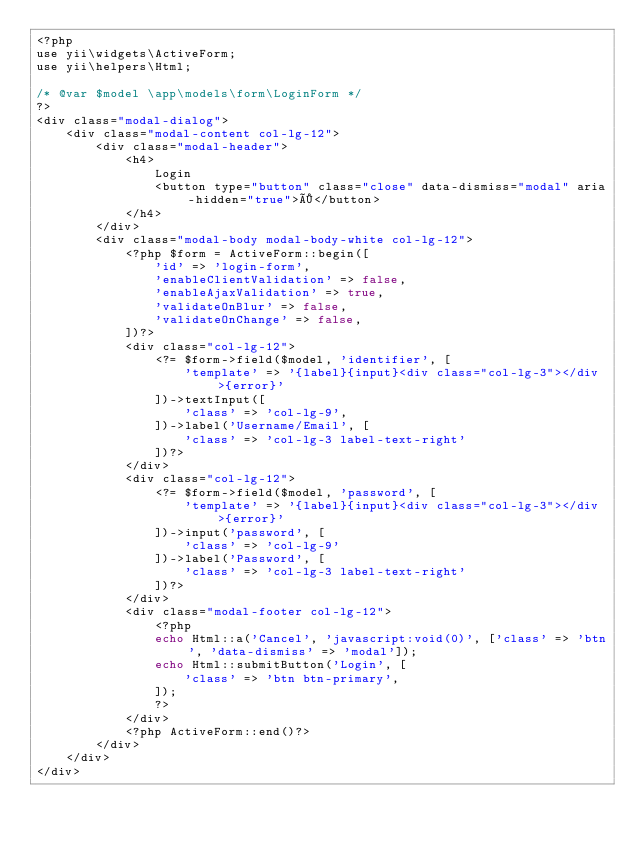Convert code to text. <code><loc_0><loc_0><loc_500><loc_500><_PHP_><?php
use yii\widgets\ActiveForm;
use yii\helpers\Html;

/* @var $model \app\models\form\LoginForm */
?>
<div class="modal-dialog">
    <div class="modal-content col-lg-12">
        <div class="modal-header">
            <h4>
                Login
                <button type="button" class="close" data-dismiss="modal" aria-hidden="true">×</button>
            </h4>
        </div>
        <div class="modal-body modal-body-white col-lg-12">
            <?php $form = ActiveForm::begin([
                'id' => 'login-form',
                'enableClientValidation' => false,
                'enableAjaxValidation' => true,
                'validateOnBlur' => false,
                'validateOnChange' => false,
            ])?>
            <div class="col-lg-12">
                <?= $form->field($model, 'identifier', [
                    'template' => '{label}{input}<div class="col-lg-3"></div>{error}'
                ])->textInput([
                    'class' => 'col-lg-9',
                ])->label('Username/Email', [
                    'class' => 'col-lg-3 label-text-right'
                ])?>
            </div>
            <div class="col-lg-12">
                <?= $form->field($model, 'password', [
                    'template' => '{label}{input}<div class="col-lg-3"></div>{error}'
                ])->input('password', [
                    'class' => 'col-lg-9'
                ])->label('Password', [
                    'class' => 'col-lg-3 label-text-right'
                ])?>
            </div>
            <div class="modal-footer col-lg-12">
                <?php
                echo Html::a('Cancel', 'javascript:void(0)', ['class' => 'btn', 'data-dismiss' => 'modal']);
                echo Html::submitButton('Login', [
                    'class' => 'btn btn-primary',
                ]);
                ?>
            </div>
            <?php ActiveForm::end()?>
        </div>
    </div>
</div></code> 